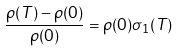<formula> <loc_0><loc_0><loc_500><loc_500>\frac { \rho ( T ) - \rho ( 0 ) } { \rho ( 0 ) } = \rho ( 0 ) \sigma _ { 1 } ( T )</formula> 